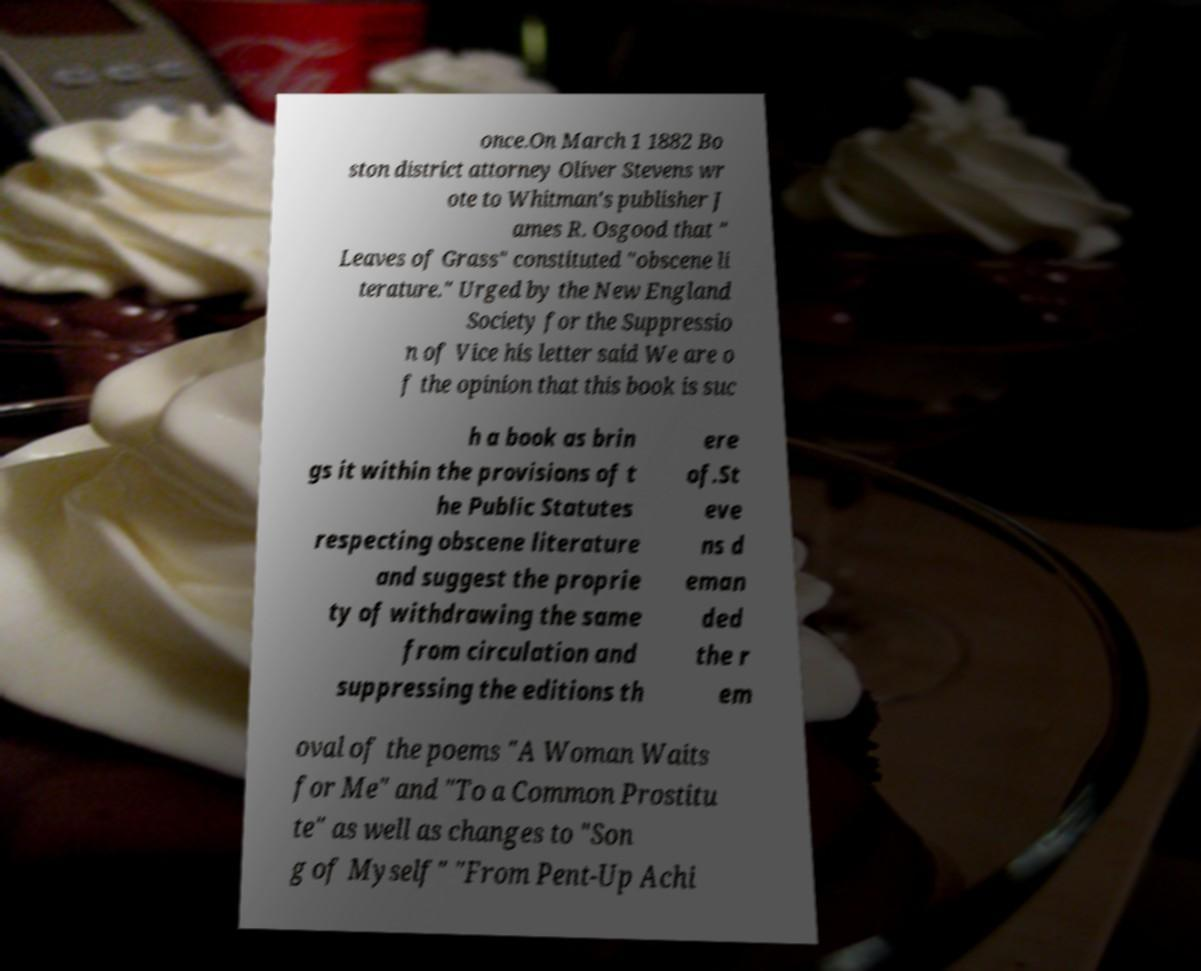Can you accurately transcribe the text from the provided image for me? once.On March 1 1882 Bo ston district attorney Oliver Stevens wr ote to Whitman's publisher J ames R. Osgood that " Leaves of Grass" constituted "obscene li terature." Urged by the New England Society for the Suppressio n of Vice his letter said We are o f the opinion that this book is suc h a book as brin gs it within the provisions of t he Public Statutes respecting obscene literature and suggest the proprie ty of withdrawing the same from circulation and suppressing the editions th ere of.St eve ns d eman ded the r em oval of the poems "A Woman Waits for Me" and "To a Common Prostitu te" as well as changes to "Son g of Myself" "From Pent-Up Achi 